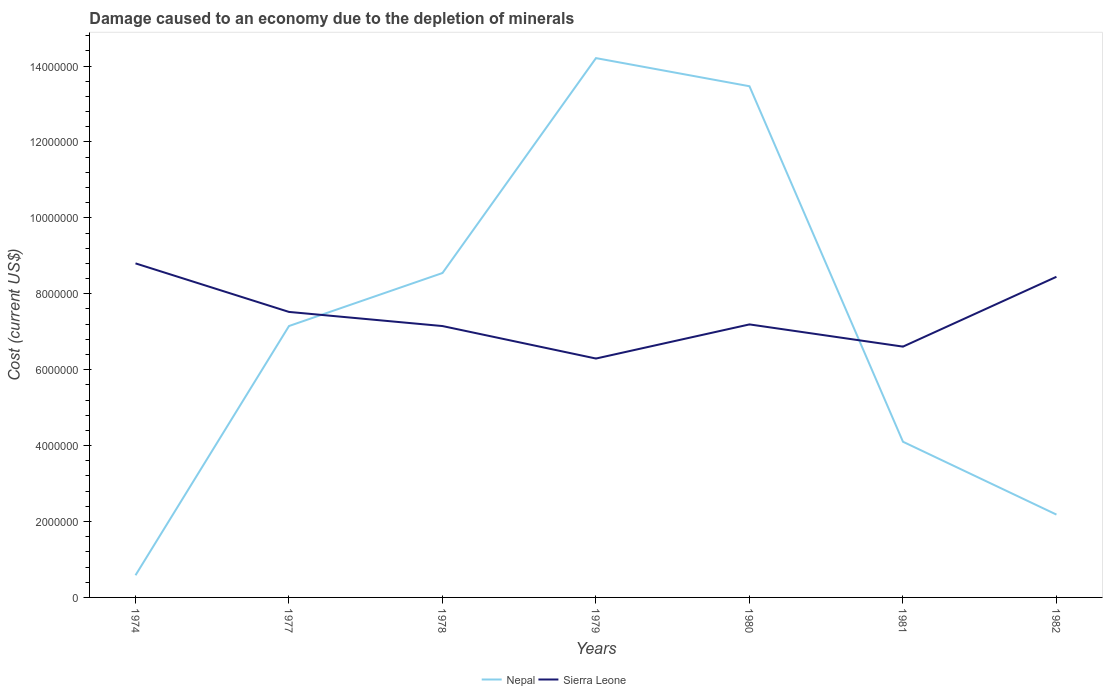Does the line corresponding to Sierra Leone intersect with the line corresponding to Nepal?
Provide a short and direct response. Yes. Across all years, what is the maximum cost of damage caused due to the depletion of minerals in Nepal?
Provide a short and direct response. 5.84e+05. In which year was the cost of damage caused due to the depletion of minerals in Nepal maximum?
Your response must be concise. 1974. What is the total cost of damage caused due to the depletion of minerals in Sierra Leone in the graph?
Ensure brevity in your answer.  -8.99e+05. What is the difference between the highest and the second highest cost of damage caused due to the depletion of minerals in Sierra Leone?
Provide a short and direct response. 2.51e+06. What is the difference between the highest and the lowest cost of damage caused due to the depletion of minerals in Sierra Leone?
Offer a very short reply. 3. How many lines are there?
Provide a succinct answer. 2. How many years are there in the graph?
Provide a succinct answer. 7. What is the difference between two consecutive major ticks on the Y-axis?
Offer a very short reply. 2.00e+06. Are the values on the major ticks of Y-axis written in scientific E-notation?
Offer a terse response. No. Does the graph contain grids?
Give a very brief answer. No. Where does the legend appear in the graph?
Your answer should be compact. Bottom center. What is the title of the graph?
Your answer should be very brief. Damage caused to an economy due to the depletion of minerals. What is the label or title of the X-axis?
Make the answer very short. Years. What is the label or title of the Y-axis?
Keep it short and to the point. Cost (current US$). What is the Cost (current US$) in Nepal in 1974?
Keep it short and to the point. 5.84e+05. What is the Cost (current US$) of Sierra Leone in 1974?
Offer a very short reply. 8.80e+06. What is the Cost (current US$) of Nepal in 1977?
Your response must be concise. 7.15e+06. What is the Cost (current US$) in Sierra Leone in 1977?
Keep it short and to the point. 7.52e+06. What is the Cost (current US$) of Nepal in 1978?
Offer a very short reply. 8.55e+06. What is the Cost (current US$) of Sierra Leone in 1978?
Ensure brevity in your answer.  7.15e+06. What is the Cost (current US$) of Nepal in 1979?
Offer a terse response. 1.42e+07. What is the Cost (current US$) of Sierra Leone in 1979?
Keep it short and to the point. 6.29e+06. What is the Cost (current US$) of Nepal in 1980?
Keep it short and to the point. 1.35e+07. What is the Cost (current US$) in Sierra Leone in 1980?
Make the answer very short. 7.19e+06. What is the Cost (current US$) in Nepal in 1981?
Your response must be concise. 4.10e+06. What is the Cost (current US$) in Sierra Leone in 1981?
Give a very brief answer. 6.61e+06. What is the Cost (current US$) of Nepal in 1982?
Your answer should be compact. 2.18e+06. What is the Cost (current US$) in Sierra Leone in 1982?
Offer a very short reply. 8.45e+06. Across all years, what is the maximum Cost (current US$) in Nepal?
Offer a terse response. 1.42e+07. Across all years, what is the maximum Cost (current US$) in Sierra Leone?
Give a very brief answer. 8.80e+06. Across all years, what is the minimum Cost (current US$) in Nepal?
Give a very brief answer. 5.84e+05. Across all years, what is the minimum Cost (current US$) of Sierra Leone?
Your response must be concise. 6.29e+06. What is the total Cost (current US$) in Nepal in the graph?
Offer a very short reply. 5.02e+07. What is the total Cost (current US$) in Sierra Leone in the graph?
Your response must be concise. 5.20e+07. What is the difference between the Cost (current US$) of Nepal in 1974 and that in 1977?
Ensure brevity in your answer.  -6.57e+06. What is the difference between the Cost (current US$) in Sierra Leone in 1974 and that in 1977?
Keep it short and to the point. 1.28e+06. What is the difference between the Cost (current US$) of Nepal in 1974 and that in 1978?
Keep it short and to the point. -7.96e+06. What is the difference between the Cost (current US$) of Sierra Leone in 1974 and that in 1978?
Make the answer very short. 1.65e+06. What is the difference between the Cost (current US$) of Nepal in 1974 and that in 1979?
Keep it short and to the point. -1.36e+07. What is the difference between the Cost (current US$) in Sierra Leone in 1974 and that in 1979?
Give a very brief answer. 2.51e+06. What is the difference between the Cost (current US$) of Nepal in 1974 and that in 1980?
Provide a succinct answer. -1.29e+07. What is the difference between the Cost (current US$) in Sierra Leone in 1974 and that in 1980?
Give a very brief answer. 1.61e+06. What is the difference between the Cost (current US$) of Nepal in 1974 and that in 1981?
Your answer should be compact. -3.52e+06. What is the difference between the Cost (current US$) of Sierra Leone in 1974 and that in 1981?
Offer a very short reply. 2.19e+06. What is the difference between the Cost (current US$) in Nepal in 1974 and that in 1982?
Keep it short and to the point. -1.60e+06. What is the difference between the Cost (current US$) in Sierra Leone in 1974 and that in 1982?
Provide a short and direct response. 3.54e+05. What is the difference between the Cost (current US$) of Nepal in 1977 and that in 1978?
Give a very brief answer. -1.40e+06. What is the difference between the Cost (current US$) in Sierra Leone in 1977 and that in 1978?
Offer a very short reply. 3.72e+05. What is the difference between the Cost (current US$) of Nepal in 1977 and that in 1979?
Give a very brief answer. -7.06e+06. What is the difference between the Cost (current US$) of Sierra Leone in 1977 and that in 1979?
Ensure brevity in your answer.  1.23e+06. What is the difference between the Cost (current US$) in Nepal in 1977 and that in 1980?
Give a very brief answer. -6.32e+06. What is the difference between the Cost (current US$) in Sierra Leone in 1977 and that in 1980?
Make the answer very short. 3.29e+05. What is the difference between the Cost (current US$) of Nepal in 1977 and that in 1981?
Your answer should be compact. 3.05e+06. What is the difference between the Cost (current US$) in Sierra Leone in 1977 and that in 1981?
Make the answer very short. 9.14e+05. What is the difference between the Cost (current US$) in Nepal in 1977 and that in 1982?
Provide a succinct answer. 4.97e+06. What is the difference between the Cost (current US$) of Sierra Leone in 1977 and that in 1982?
Make the answer very short. -9.26e+05. What is the difference between the Cost (current US$) of Nepal in 1978 and that in 1979?
Provide a short and direct response. -5.66e+06. What is the difference between the Cost (current US$) of Sierra Leone in 1978 and that in 1979?
Keep it short and to the point. 8.56e+05. What is the difference between the Cost (current US$) of Nepal in 1978 and that in 1980?
Offer a terse response. -4.92e+06. What is the difference between the Cost (current US$) of Sierra Leone in 1978 and that in 1980?
Give a very brief answer. -4.34e+04. What is the difference between the Cost (current US$) in Nepal in 1978 and that in 1981?
Provide a short and direct response. 4.45e+06. What is the difference between the Cost (current US$) of Sierra Leone in 1978 and that in 1981?
Your answer should be very brief. 5.42e+05. What is the difference between the Cost (current US$) in Nepal in 1978 and that in 1982?
Your answer should be very brief. 6.36e+06. What is the difference between the Cost (current US$) of Sierra Leone in 1978 and that in 1982?
Your response must be concise. -1.30e+06. What is the difference between the Cost (current US$) in Nepal in 1979 and that in 1980?
Offer a very short reply. 7.41e+05. What is the difference between the Cost (current US$) in Sierra Leone in 1979 and that in 1980?
Your answer should be compact. -8.99e+05. What is the difference between the Cost (current US$) in Nepal in 1979 and that in 1981?
Offer a very short reply. 1.01e+07. What is the difference between the Cost (current US$) of Sierra Leone in 1979 and that in 1981?
Provide a short and direct response. -3.14e+05. What is the difference between the Cost (current US$) in Nepal in 1979 and that in 1982?
Provide a succinct answer. 1.20e+07. What is the difference between the Cost (current US$) of Sierra Leone in 1979 and that in 1982?
Your response must be concise. -2.15e+06. What is the difference between the Cost (current US$) of Nepal in 1980 and that in 1981?
Your response must be concise. 9.37e+06. What is the difference between the Cost (current US$) in Sierra Leone in 1980 and that in 1981?
Ensure brevity in your answer.  5.85e+05. What is the difference between the Cost (current US$) in Nepal in 1980 and that in 1982?
Ensure brevity in your answer.  1.13e+07. What is the difference between the Cost (current US$) of Sierra Leone in 1980 and that in 1982?
Your answer should be compact. -1.25e+06. What is the difference between the Cost (current US$) of Nepal in 1981 and that in 1982?
Your answer should be compact. 1.92e+06. What is the difference between the Cost (current US$) in Sierra Leone in 1981 and that in 1982?
Provide a succinct answer. -1.84e+06. What is the difference between the Cost (current US$) of Nepal in 1974 and the Cost (current US$) of Sierra Leone in 1977?
Offer a very short reply. -6.94e+06. What is the difference between the Cost (current US$) of Nepal in 1974 and the Cost (current US$) of Sierra Leone in 1978?
Give a very brief answer. -6.57e+06. What is the difference between the Cost (current US$) in Nepal in 1974 and the Cost (current US$) in Sierra Leone in 1979?
Your answer should be compact. -5.71e+06. What is the difference between the Cost (current US$) in Nepal in 1974 and the Cost (current US$) in Sierra Leone in 1980?
Offer a terse response. -6.61e+06. What is the difference between the Cost (current US$) in Nepal in 1974 and the Cost (current US$) in Sierra Leone in 1981?
Give a very brief answer. -6.02e+06. What is the difference between the Cost (current US$) of Nepal in 1974 and the Cost (current US$) of Sierra Leone in 1982?
Offer a terse response. -7.86e+06. What is the difference between the Cost (current US$) in Nepal in 1977 and the Cost (current US$) in Sierra Leone in 1978?
Provide a short and direct response. 777.02. What is the difference between the Cost (current US$) of Nepal in 1977 and the Cost (current US$) of Sierra Leone in 1979?
Make the answer very short. 8.57e+05. What is the difference between the Cost (current US$) of Nepal in 1977 and the Cost (current US$) of Sierra Leone in 1980?
Your answer should be very brief. -4.26e+04. What is the difference between the Cost (current US$) in Nepal in 1977 and the Cost (current US$) in Sierra Leone in 1981?
Provide a short and direct response. 5.43e+05. What is the difference between the Cost (current US$) of Nepal in 1977 and the Cost (current US$) of Sierra Leone in 1982?
Offer a very short reply. -1.30e+06. What is the difference between the Cost (current US$) of Nepal in 1978 and the Cost (current US$) of Sierra Leone in 1979?
Provide a short and direct response. 2.25e+06. What is the difference between the Cost (current US$) of Nepal in 1978 and the Cost (current US$) of Sierra Leone in 1980?
Make the answer very short. 1.35e+06. What is the difference between the Cost (current US$) of Nepal in 1978 and the Cost (current US$) of Sierra Leone in 1981?
Provide a short and direct response. 1.94e+06. What is the difference between the Cost (current US$) of Nepal in 1978 and the Cost (current US$) of Sierra Leone in 1982?
Ensure brevity in your answer.  9.95e+04. What is the difference between the Cost (current US$) in Nepal in 1979 and the Cost (current US$) in Sierra Leone in 1980?
Make the answer very short. 7.02e+06. What is the difference between the Cost (current US$) in Nepal in 1979 and the Cost (current US$) in Sierra Leone in 1981?
Your response must be concise. 7.60e+06. What is the difference between the Cost (current US$) in Nepal in 1979 and the Cost (current US$) in Sierra Leone in 1982?
Keep it short and to the point. 5.76e+06. What is the difference between the Cost (current US$) of Nepal in 1980 and the Cost (current US$) of Sierra Leone in 1981?
Your response must be concise. 6.86e+06. What is the difference between the Cost (current US$) of Nepal in 1980 and the Cost (current US$) of Sierra Leone in 1982?
Offer a terse response. 5.02e+06. What is the difference between the Cost (current US$) in Nepal in 1981 and the Cost (current US$) in Sierra Leone in 1982?
Provide a short and direct response. -4.35e+06. What is the average Cost (current US$) of Nepal per year?
Provide a short and direct response. 7.18e+06. What is the average Cost (current US$) in Sierra Leone per year?
Provide a succinct answer. 7.43e+06. In the year 1974, what is the difference between the Cost (current US$) of Nepal and Cost (current US$) of Sierra Leone?
Offer a very short reply. -8.22e+06. In the year 1977, what is the difference between the Cost (current US$) of Nepal and Cost (current US$) of Sierra Leone?
Keep it short and to the point. -3.72e+05. In the year 1978, what is the difference between the Cost (current US$) in Nepal and Cost (current US$) in Sierra Leone?
Ensure brevity in your answer.  1.40e+06. In the year 1979, what is the difference between the Cost (current US$) in Nepal and Cost (current US$) in Sierra Leone?
Provide a short and direct response. 7.92e+06. In the year 1980, what is the difference between the Cost (current US$) in Nepal and Cost (current US$) in Sierra Leone?
Make the answer very short. 6.28e+06. In the year 1981, what is the difference between the Cost (current US$) in Nepal and Cost (current US$) in Sierra Leone?
Your answer should be very brief. -2.51e+06. In the year 1982, what is the difference between the Cost (current US$) in Nepal and Cost (current US$) in Sierra Leone?
Keep it short and to the point. -6.27e+06. What is the ratio of the Cost (current US$) of Nepal in 1974 to that in 1977?
Your answer should be compact. 0.08. What is the ratio of the Cost (current US$) of Sierra Leone in 1974 to that in 1977?
Your answer should be very brief. 1.17. What is the ratio of the Cost (current US$) in Nepal in 1974 to that in 1978?
Make the answer very short. 0.07. What is the ratio of the Cost (current US$) in Sierra Leone in 1974 to that in 1978?
Your answer should be compact. 1.23. What is the ratio of the Cost (current US$) in Nepal in 1974 to that in 1979?
Keep it short and to the point. 0.04. What is the ratio of the Cost (current US$) in Sierra Leone in 1974 to that in 1979?
Your answer should be very brief. 1.4. What is the ratio of the Cost (current US$) in Nepal in 1974 to that in 1980?
Offer a terse response. 0.04. What is the ratio of the Cost (current US$) in Sierra Leone in 1974 to that in 1980?
Make the answer very short. 1.22. What is the ratio of the Cost (current US$) of Nepal in 1974 to that in 1981?
Ensure brevity in your answer.  0.14. What is the ratio of the Cost (current US$) in Sierra Leone in 1974 to that in 1981?
Offer a very short reply. 1.33. What is the ratio of the Cost (current US$) of Nepal in 1974 to that in 1982?
Offer a terse response. 0.27. What is the ratio of the Cost (current US$) of Sierra Leone in 1974 to that in 1982?
Your answer should be compact. 1.04. What is the ratio of the Cost (current US$) in Nepal in 1977 to that in 1978?
Provide a succinct answer. 0.84. What is the ratio of the Cost (current US$) of Sierra Leone in 1977 to that in 1978?
Your answer should be compact. 1.05. What is the ratio of the Cost (current US$) in Nepal in 1977 to that in 1979?
Keep it short and to the point. 0.5. What is the ratio of the Cost (current US$) of Sierra Leone in 1977 to that in 1979?
Your response must be concise. 1.2. What is the ratio of the Cost (current US$) of Nepal in 1977 to that in 1980?
Provide a succinct answer. 0.53. What is the ratio of the Cost (current US$) of Sierra Leone in 1977 to that in 1980?
Your answer should be very brief. 1.05. What is the ratio of the Cost (current US$) in Nepal in 1977 to that in 1981?
Offer a terse response. 1.74. What is the ratio of the Cost (current US$) in Sierra Leone in 1977 to that in 1981?
Keep it short and to the point. 1.14. What is the ratio of the Cost (current US$) of Nepal in 1977 to that in 1982?
Ensure brevity in your answer.  3.28. What is the ratio of the Cost (current US$) in Sierra Leone in 1977 to that in 1982?
Give a very brief answer. 0.89. What is the ratio of the Cost (current US$) in Nepal in 1978 to that in 1979?
Offer a very short reply. 0.6. What is the ratio of the Cost (current US$) in Sierra Leone in 1978 to that in 1979?
Ensure brevity in your answer.  1.14. What is the ratio of the Cost (current US$) of Nepal in 1978 to that in 1980?
Your answer should be compact. 0.63. What is the ratio of the Cost (current US$) in Nepal in 1978 to that in 1981?
Offer a terse response. 2.08. What is the ratio of the Cost (current US$) of Sierra Leone in 1978 to that in 1981?
Ensure brevity in your answer.  1.08. What is the ratio of the Cost (current US$) of Nepal in 1978 to that in 1982?
Offer a terse response. 3.92. What is the ratio of the Cost (current US$) in Sierra Leone in 1978 to that in 1982?
Keep it short and to the point. 0.85. What is the ratio of the Cost (current US$) in Nepal in 1979 to that in 1980?
Make the answer very short. 1.05. What is the ratio of the Cost (current US$) of Sierra Leone in 1979 to that in 1980?
Provide a succinct answer. 0.88. What is the ratio of the Cost (current US$) of Nepal in 1979 to that in 1981?
Your answer should be compact. 3.46. What is the ratio of the Cost (current US$) in Sierra Leone in 1979 to that in 1981?
Make the answer very short. 0.95. What is the ratio of the Cost (current US$) in Nepal in 1979 to that in 1982?
Offer a terse response. 6.51. What is the ratio of the Cost (current US$) of Sierra Leone in 1979 to that in 1982?
Give a very brief answer. 0.74. What is the ratio of the Cost (current US$) of Nepal in 1980 to that in 1981?
Your response must be concise. 3.28. What is the ratio of the Cost (current US$) in Sierra Leone in 1980 to that in 1981?
Your answer should be very brief. 1.09. What is the ratio of the Cost (current US$) in Nepal in 1980 to that in 1982?
Offer a terse response. 6.17. What is the ratio of the Cost (current US$) in Sierra Leone in 1980 to that in 1982?
Provide a succinct answer. 0.85. What is the ratio of the Cost (current US$) of Nepal in 1981 to that in 1982?
Ensure brevity in your answer.  1.88. What is the ratio of the Cost (current US$) in Sierra Leone in 1981 to that in 1982?
Keep it short and to the point. 0.78. What is the difference between the highest and the second highest Cost (current US$) in Nepal?
Keep it short and to the point. 7.41e+05. What is the difference between the highest and the second highest Cost (current US$) in Sierra Leone?
Offer a very short reply. 3.54e+05. What is the difference between the highest and the lowest Cost (current US$) of Nepal?
Offer a terse response. 1.36e+07. What is the difference between the highest and the lowest Cost (current US$) of Sierra Leone?
Make the answer very short. 2.51e+06. 